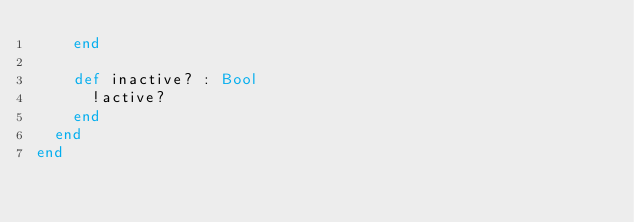<code> <loc_0><loc_0><loc_500><loc_500><_Crystal_>    end

    def inactive? : Bool
      !active?
    end
  end
end
</code> 